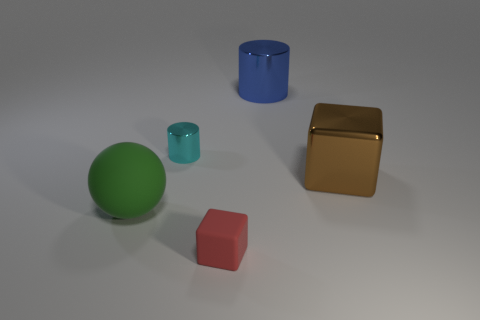Add 4 big blue rubber things. How many objects exist? 9 Subtract all spheres. How many objects are left? 4 Add 3 tiny cubes. How many tiny cubes are left? 4 Add 2 brown cubes. How many brown cubes exist? 3 Subtract 0 green cylinders. How many objects are left? 5 Subtract all big objects. Subtract all tiny red rubber things. How many objects are left? 1 